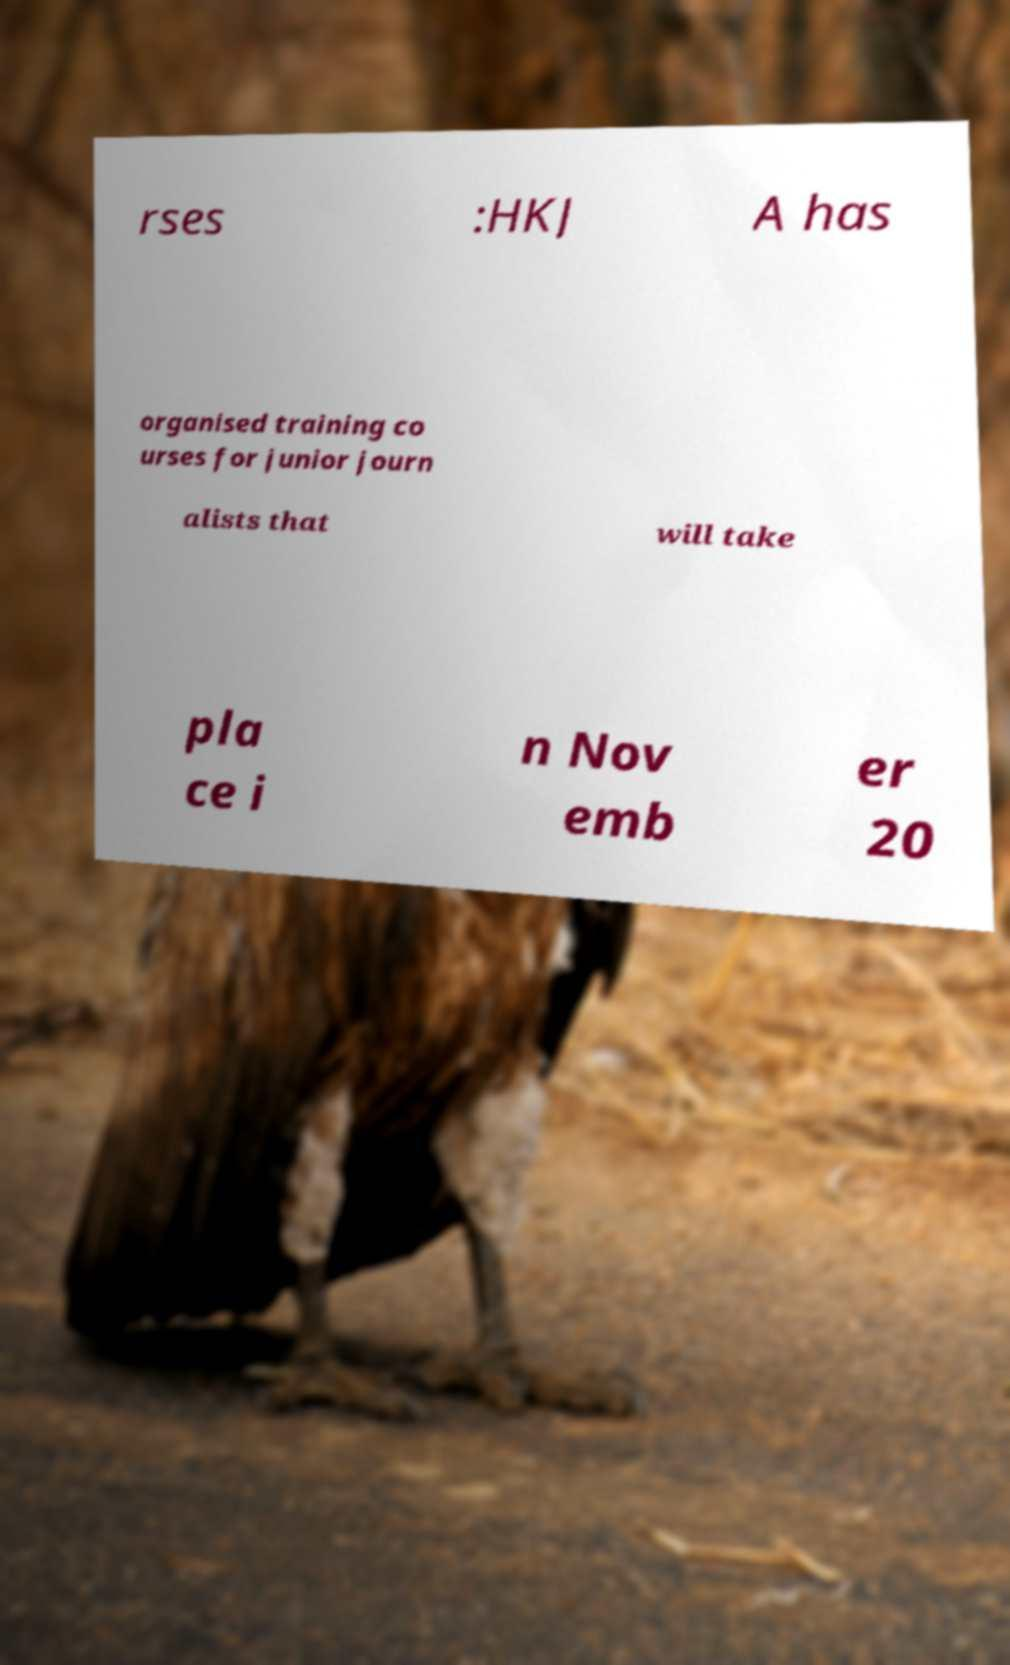Could you extract and type out the text from this image? rses :HKJ A has organised training co urses for junior journ alists that will take pla ce i n Nov emb er 20 